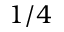Convert formula to latex. <formula><loc_0><loc_0><loc_500><loc_500>1 / 4</formula> 